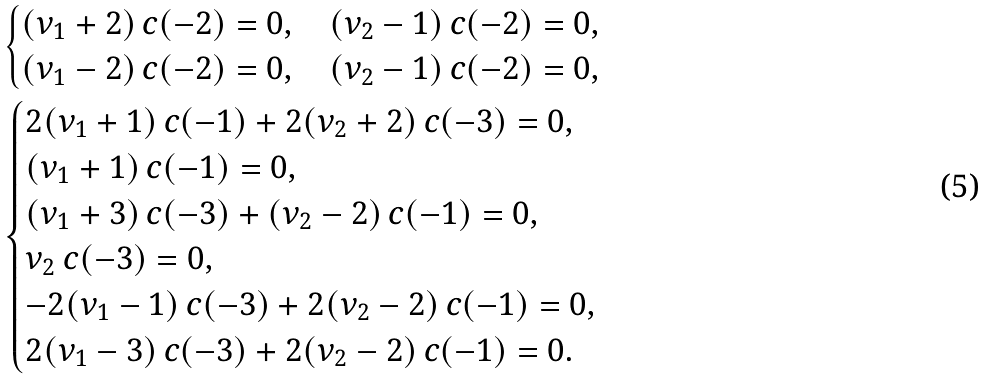<formula> <loc_0><loc_0><loc_500><loc_500>& \begin{cases} ( \nu _ { 1 } + 2 ) \, c ( - 2 ) = 0 , \quad ( \nu _ { 2 } - 1 ) \, c ( - 2 ) = 0 , \\ ( \nu _ { 1 } - 2 ) \, c ( - 2 ) = 0 , \quad ( \nu _ { 2 } - 1 ) \, c ( - 2 ) = 0 , \end{cases} \\ & \begin{cases} 2 ( \nu _ { 1 } + 1 ) \, c ( - 1 ) + 2 ( \nu _ { 2 } + 2 ) \, c ( - 3 ) = 0 , \\ ( \nu _ { 1 } + 1 ) \, c ( - 1 ) = 0 , \\ ( \nu _ { 1 } + 3 ) \, c ( - 3 ) + ( \nu _ { 2 } - 2 ) \, c ( - 1 ) = 0 , \\ \nu _ { 2 } \, c ( - 3 ) = 0 , \\ - 2 ( \nu _ { 1 } - 1 ) \, c ( - 3 ) + 2 ( \nu _ { 2 } - 2 ) \, c ( - 1 ) = 0 , \\ 2 ( \nu _ { 1 } - 3 ) \, c ( - 3 ) + 2 ( \nu _ { 2 } - 2 ) \, c ( - 1 ) = 0 . \end{cases}</formula> 